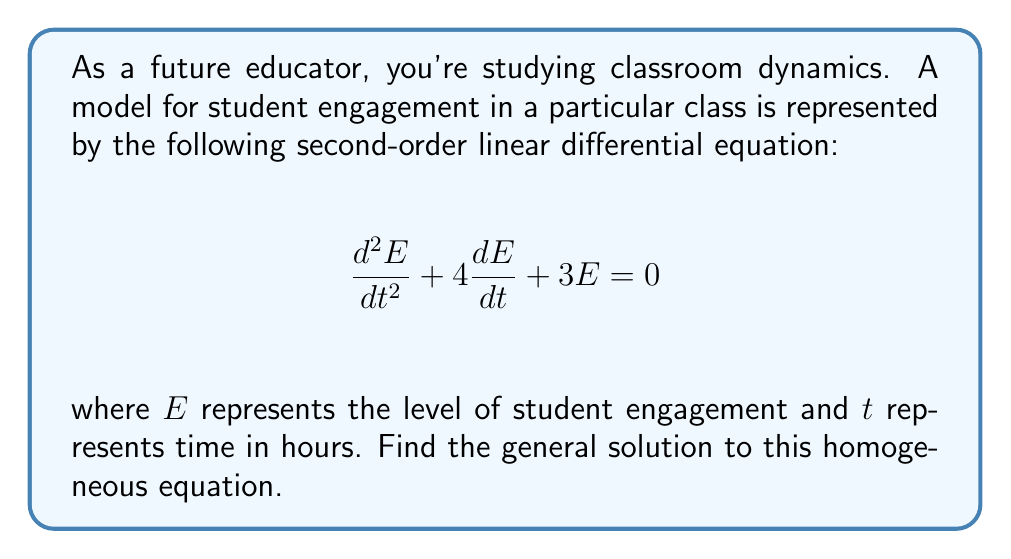Solve this math problem. To solve this homogeneous second-order linear equation, we follow these steps:

1) First, we identify the characteristic equation:
   $$r^2 + 4r + 3 = 0$$

2) We solve this quadratic equation using the quadratic formula:
   $$r = \frac{-b \pm \sqrt{b^2 - 4ac}}{2a}$$
   
   Here, $a=1$, $b=4$, and $c=3$

3) Substituting these values:
   $$r = \frac{-4 \pm \sqrt{16 - 12}}{2} = \frac{-4 \pm \sqrt{4}}{2} = \frac{-4 \pm 2}{2}$$

4) This gives us two distinct real roots:
   $$r_1 = \frac{-4 + 2}{2} = -1$$
   $$r_2 = \frac{-4 - 2}{2} = -3$$

5) The general solution for a second-order linear equation with distinct real roots is:
   $$E(t) = c_1e^{r_1t} + c_2e^{r_2t}$$

6) Substituting our roots:
   $$E(t) = c_1e^{-t} + c_2e^{-3t}$$

Where $c_1$ and $c_2$ are arbitrary constants that can be determined by initial conditions.
Answer: $$E(t) = c_1e^{-t} + c_2e^{-3t}$$ 